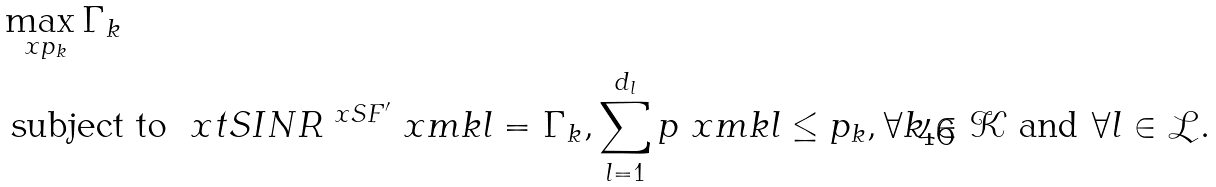Convert formula to latex. <formula><loc_0><loc_0><loc_500><loc_500>& \max _ { \ x p _ { k } } \Gamma _ { k } \\ & \text { subject to } \ x t S I N R ^ { \ x S F ^ { \prime } } \ x m k l = \Gamma _ { k } , \sum _ { l = 1 } ^ { d _ { l } } p \ x m k l \leq p _ { k } , \forall k \in \mathcal { K } \text { and } \forall l \in \mathcal { L } .</formula> 